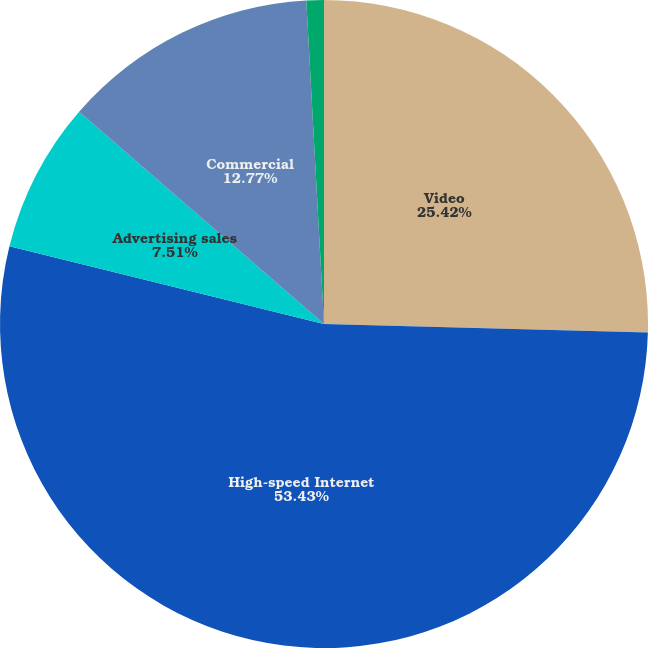Convert chart to OTSL. <chart><loc_0><loc_0><loc_500><loc_500><pie_chart><fcel>Video<fcel>High-speed Internet<fcel>Advertising sales<fcel>Commercial<fcel>Other<nl><fcel>25.42%<fcel>53.44%<fcel>7.51%<fcel>12.77%<fcel>0.87%<nl></chart> 